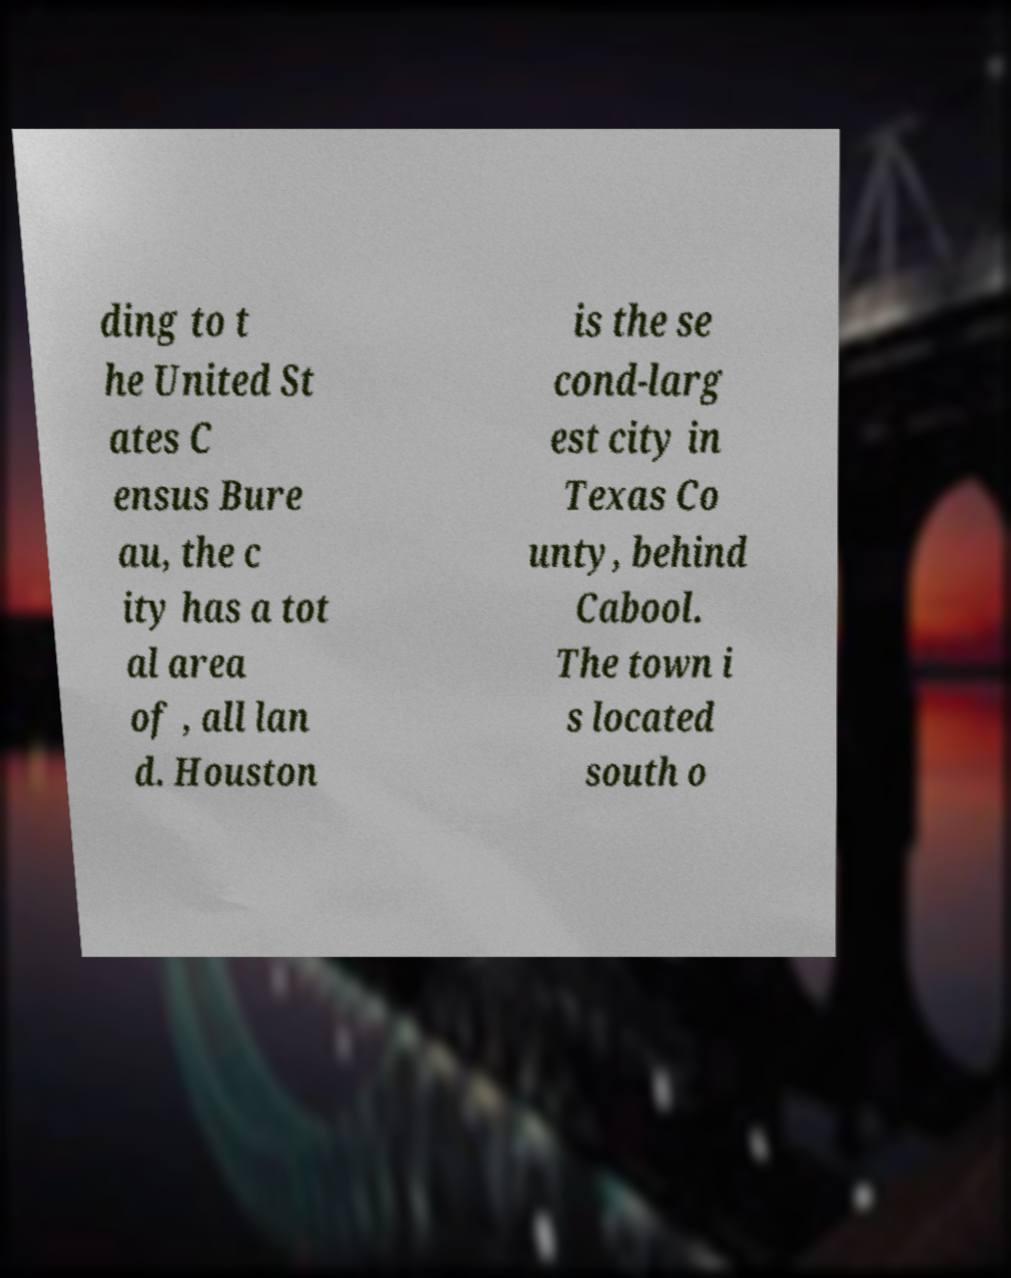There's text embedded in this image that I need extracted. Can you transcribe it verbatim? ding to t he United St ates C ensus Bure au, the c ity has a tot al area of , all lan d. Houston is the se cond-larg est city in Texas Co unty, behind Cabool. The town i s located south o 